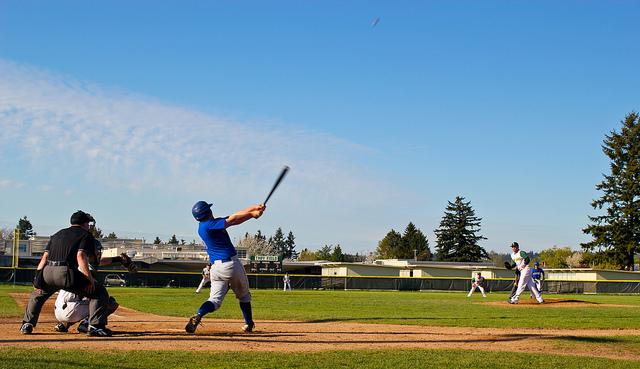Did he hit the ball?
Short answer required. Yes. Are there clouds in the sky?
Be succinct. Yes. What color is the hitters shirt?
Keep it brief. Blue. 